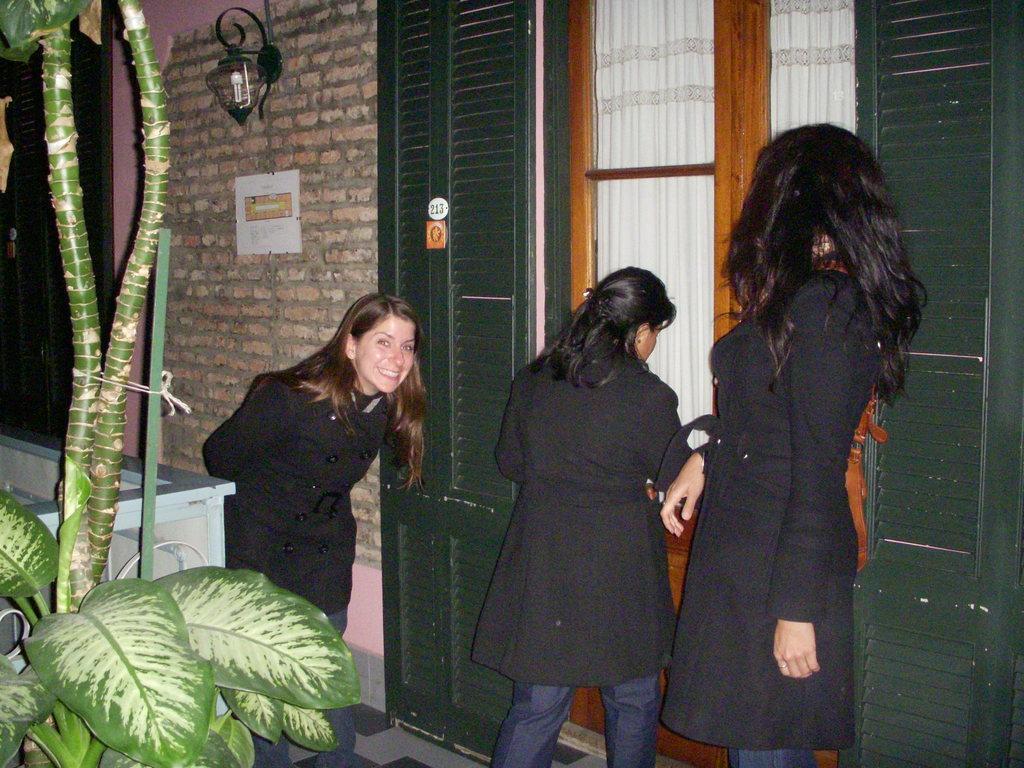In one or two sentences, can you explain what this image depicts? In this picture I can see three women are standing and wearing black color dresses. In the background I can see a wall which has lights. Here I can see a door and white color curtains. On the left side I can see tree. 